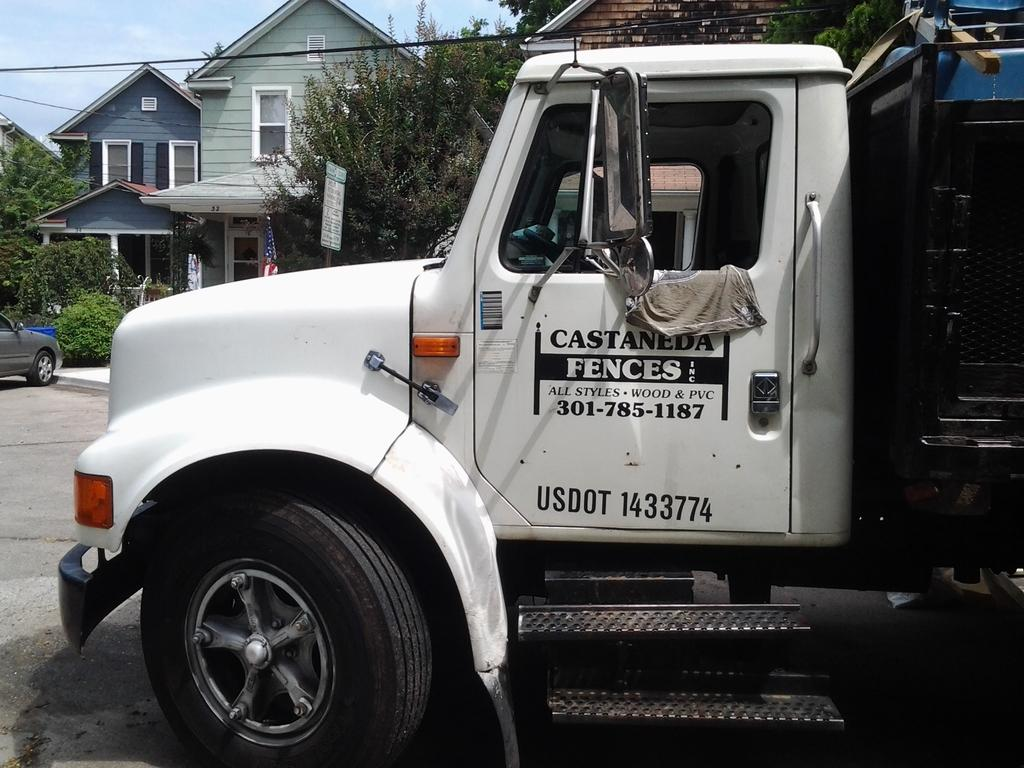What can be seen on the road in the image? There are vehicles on the road in the image. What is visible in the background of the image? There are buildings, trees, boards, wires, a flag, and bushes in the background of the image. What is visible at the top of the image? The sky is visible at the top of the image. What type of condition is the brake in on the vehicle in the image? There is no information about the condition of the brake or any specific vehicle in the image. Can you provide a receipt for the items seen in the image? There is no need for a receipt, as the image is a visual, and no items are being sold or purchased. 